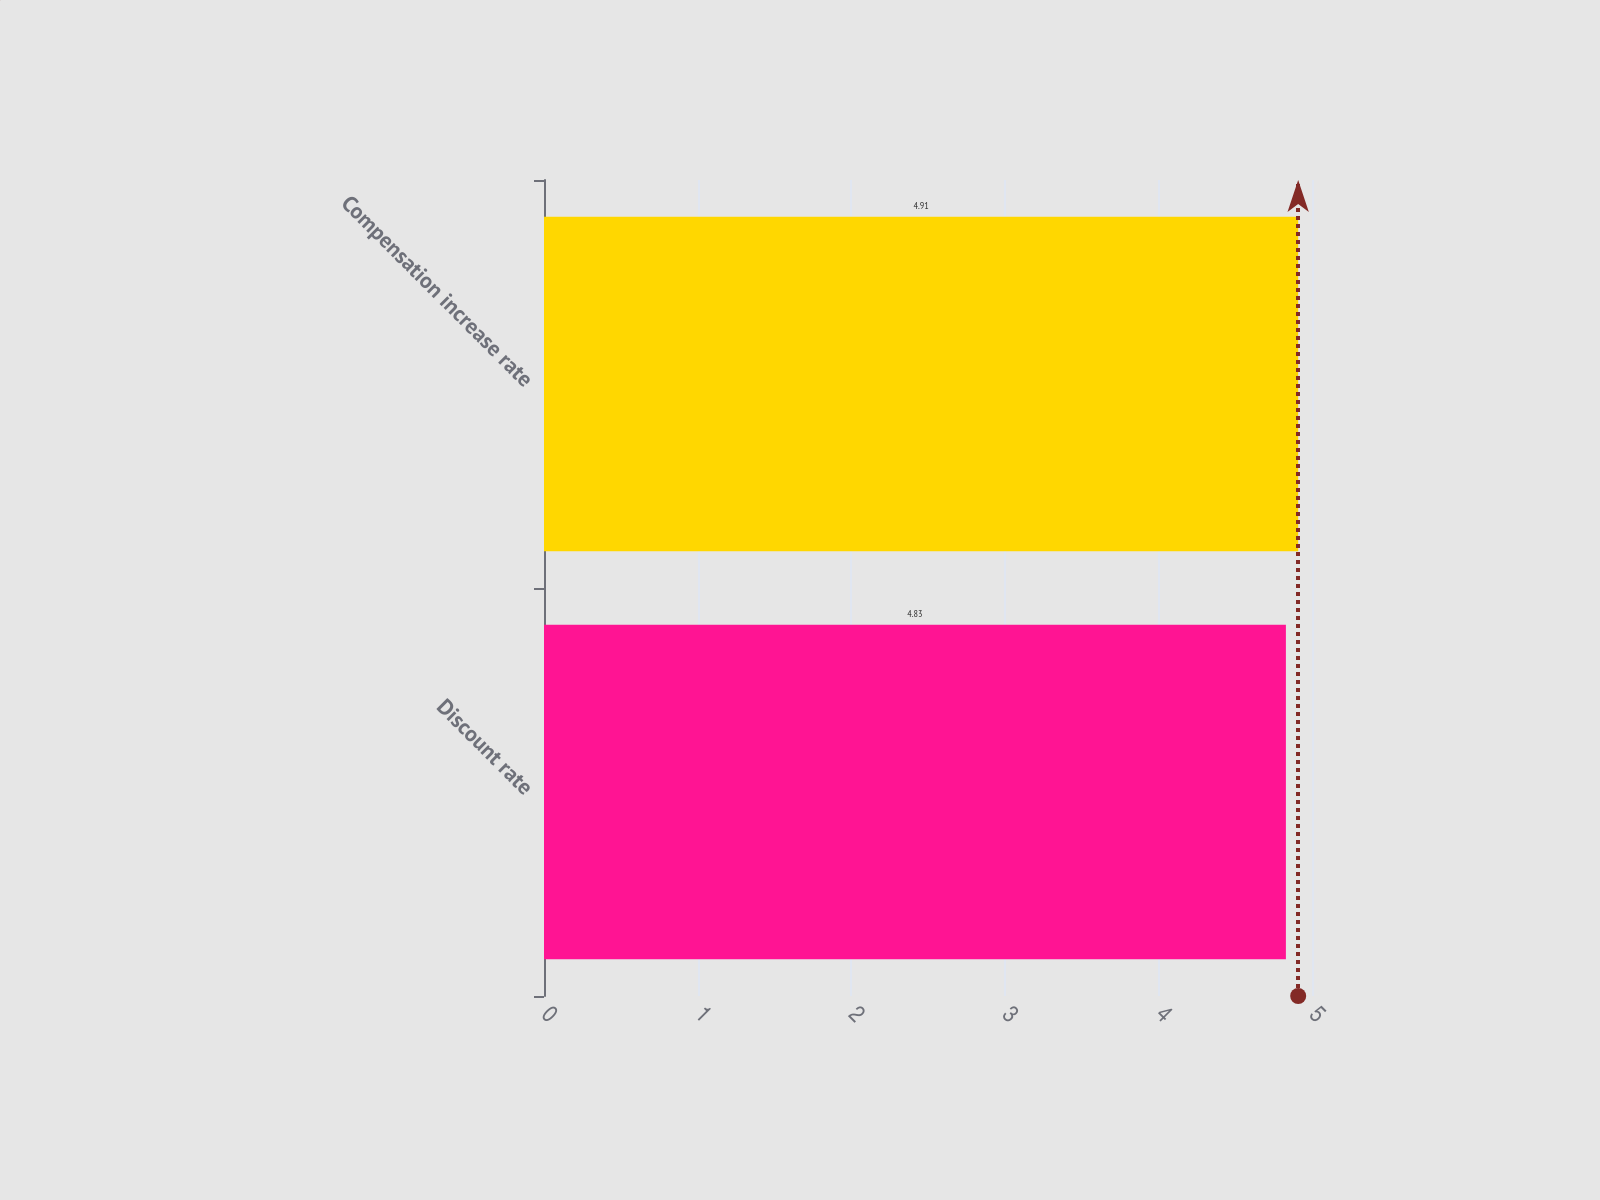Convert chart to OTSL. <chart><loc_0><loc_0><loc_500><loc_500><bar_chart><fcel>Discount rate<fcel>Compensation increase rate<nl><fcel>4.83<fcel>4.91<nl></chart> 